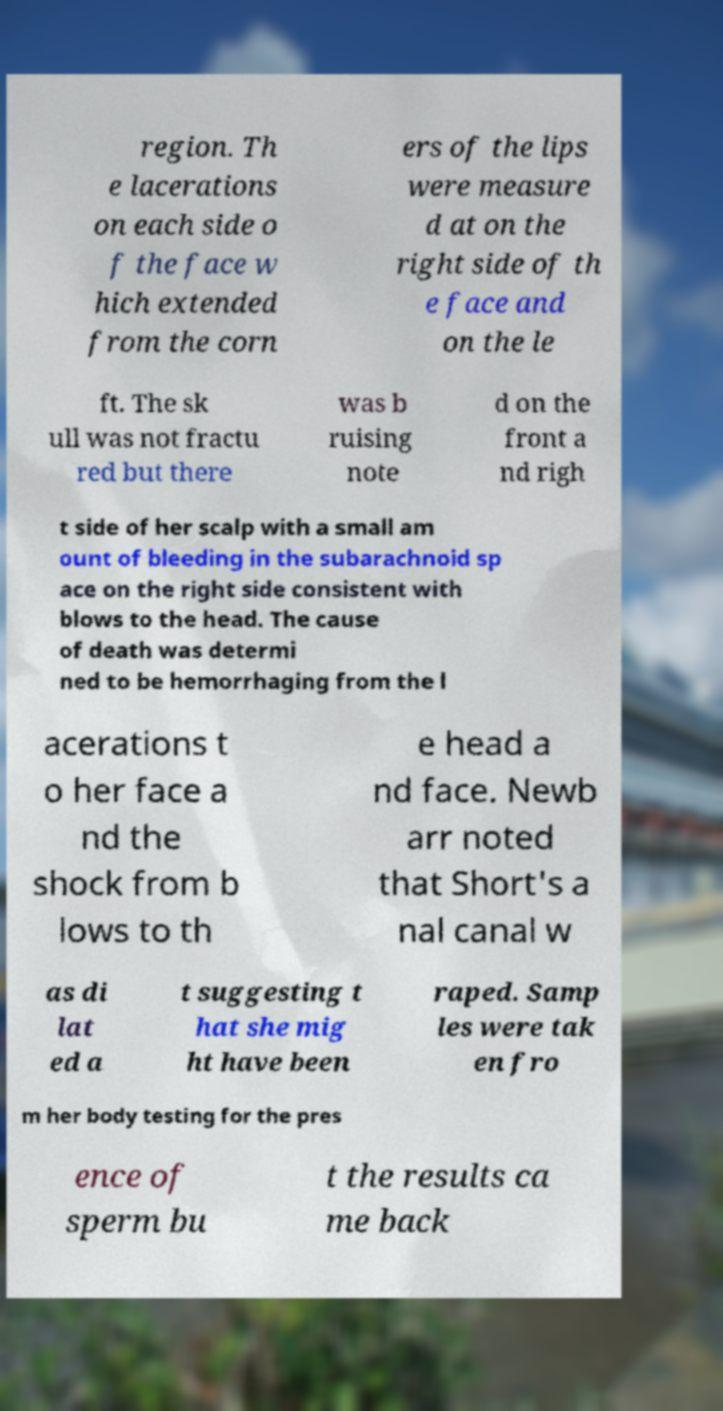I need the written content from this picture converted into text. Can you do that? region. Th e lacerations on each side o f the face w hich extended from the corn ers of the lips were measure d at on the right side of th e face and on the le ft. The sk ull was not fractu red but there was b ruising note d on the front a nd righ t side of her scalp with a small am ount of bleeding in the subarachnoid sp ace on the right side consistent with blows to the head. The cause of death was determi ned to be hemorrhaging from the l acerations t o her face a nd the shock from b lows to th e head a nd face. Newb arr noted that Short's a nal canal w as di lat ed a t suggesting t hat she mig ht have been raped. Samp les were tak en fro m her body testing for the pres ence of sperm bu t the results ca me back 